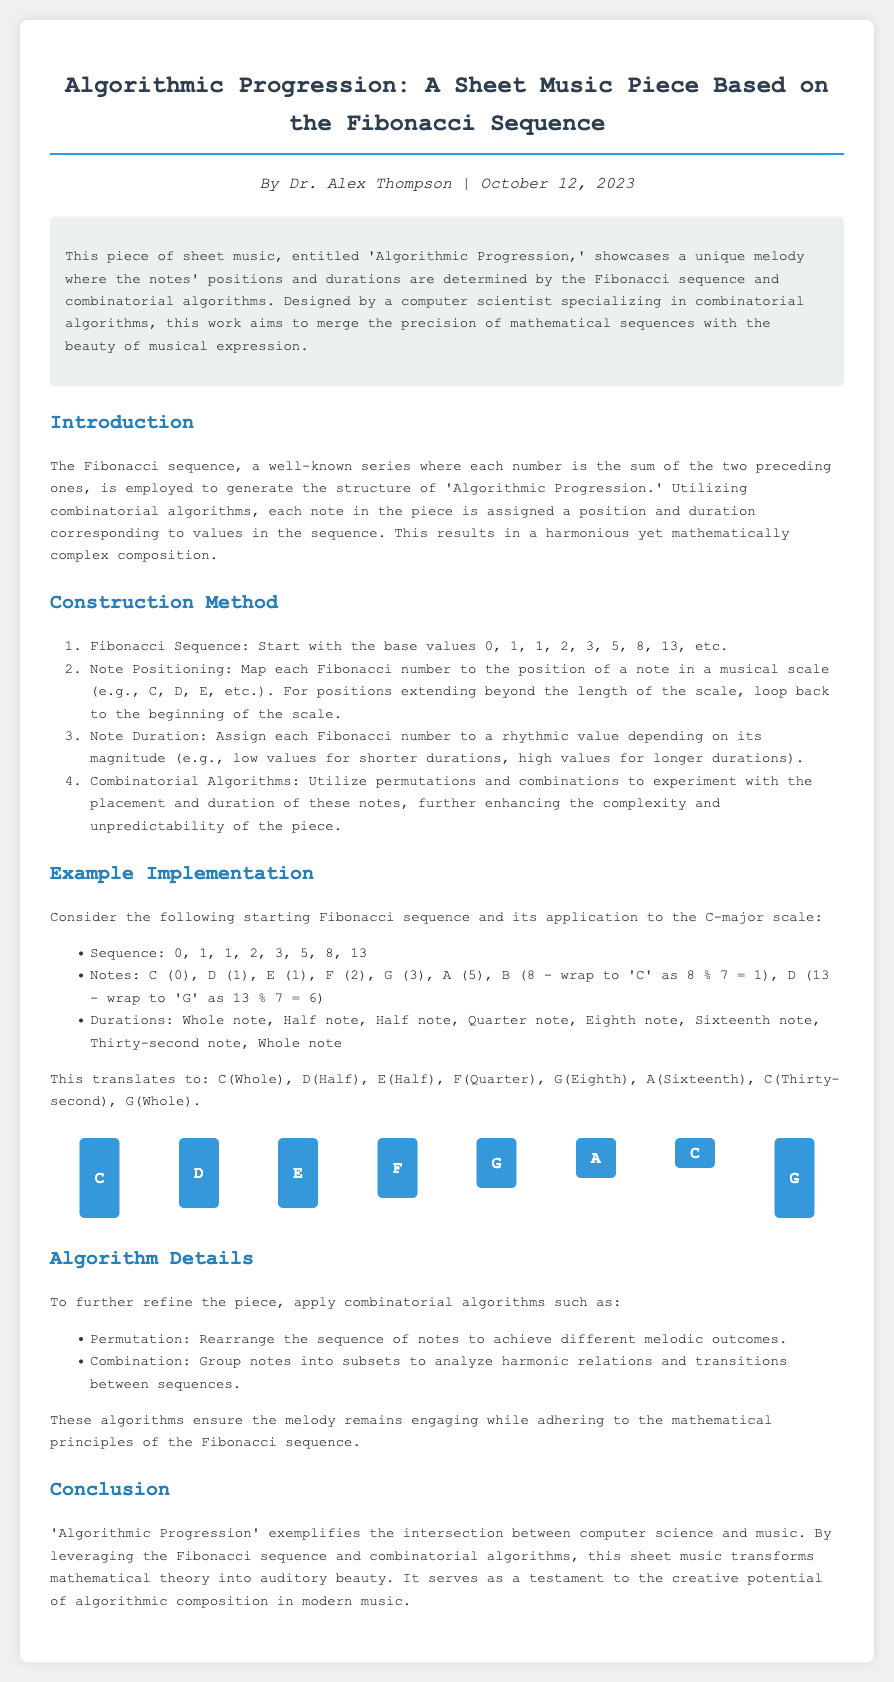What is the title of the sheet music? The title of the sheet music is provided at the top of the document.
Answer: Algorithmic Progression Who is the author of this sheet music? The author's name is mentioned in the author-date section of the document.
Answer: Dr. Alex Thompson What date was the document created? The date of creation is presented in the author-date section.
Answer: October 12, 2023 What sequence is used to determine the structure of the piece? The document specifies the mathematical sequence used for the composition.
Answer: Fibonacci sequence What musical scale is referenced in the example implementation? The scale mentioned in the example implementation section relates directly to the notes mapped from the sequence.
Answer: C-major scale Which note corresponds to the Fibonacci number 3? The document lists note positioning based on Fibonacci numbers.
Answer: G What type of note is assigned to the Fibonacci number 5? Each Fibonacci number has a corresponding duration assigned in the document.
Answer: Sixteenth note What combinatorial method is suggested for rearranging the sequence of notes? The document discusses specific combinatorial algorithms applicable to music composition.
Answer: Permutation What is the purpose of using combinatorial algorithms in this music piece? The document provides reasoning for applying these algorithms to enhance the composition's complexity.
Answer: Enhance the complexity and unpredictability 